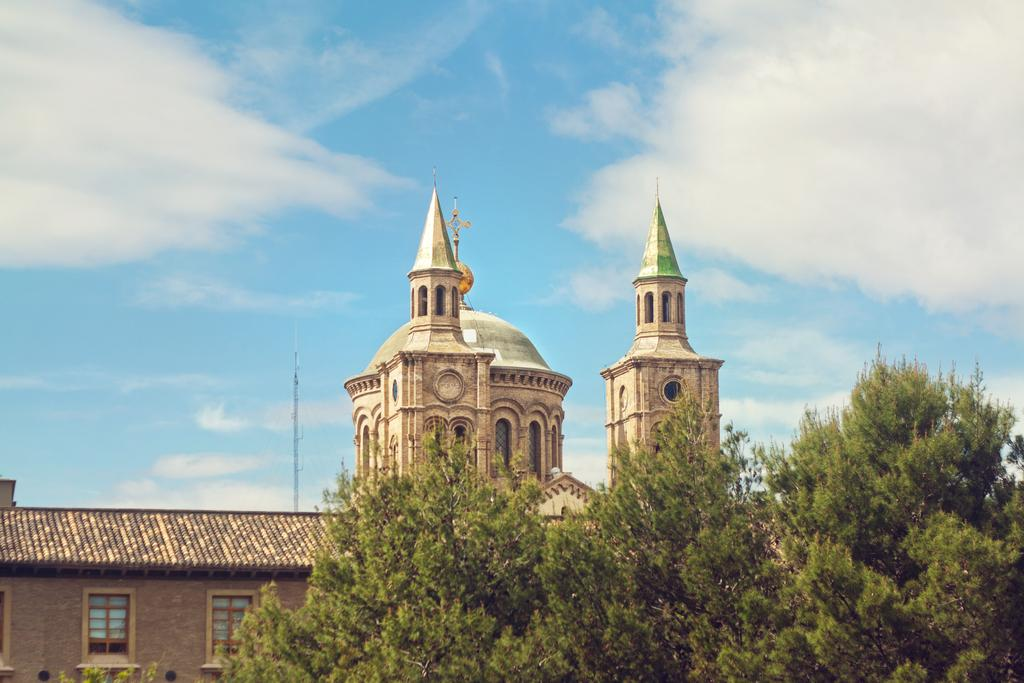What type of vegetation is present at the bottom of the image? There are trees at the bottom side of the image. What is the main architectural feature in the center of the image? There is a palace in the center of the image. What specific detail can be observed about the palace? The palace has windows. What type of calculator can be seen in the image? There is no calculator present in the image. Who is the daughter of the palace owner in the image? There is no information about a daughter or palace owner in the image. 